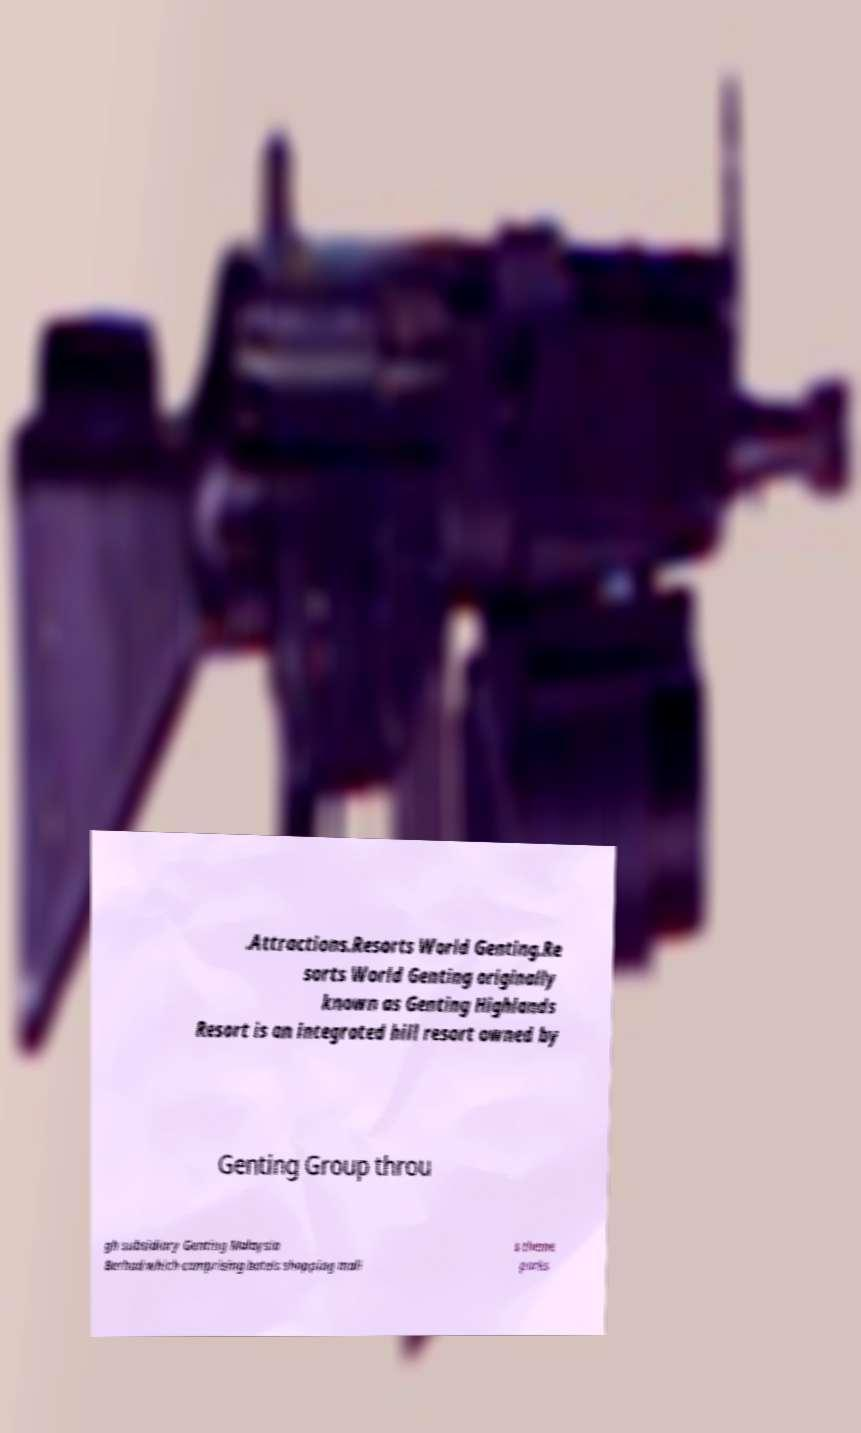Please read and relay the text visible in this image. What does it say? .Attractions.Resorts World Genting.Re sorts World Genting originally known as Genting Highlands Resort is an integrated hill resort owned by Genting Group throu gh subsidiary Genting Malaysia Berhad which comprising hotels shopping mall s theme parks 